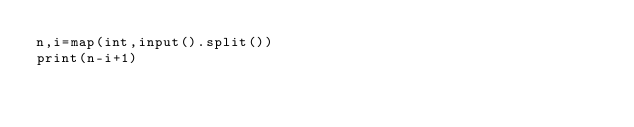Convert code to text. <code><loc_0><loc_0><loc_500><loc_500><_Python_>n,i=map(int,input().split())
print(n-i+1)</code> 